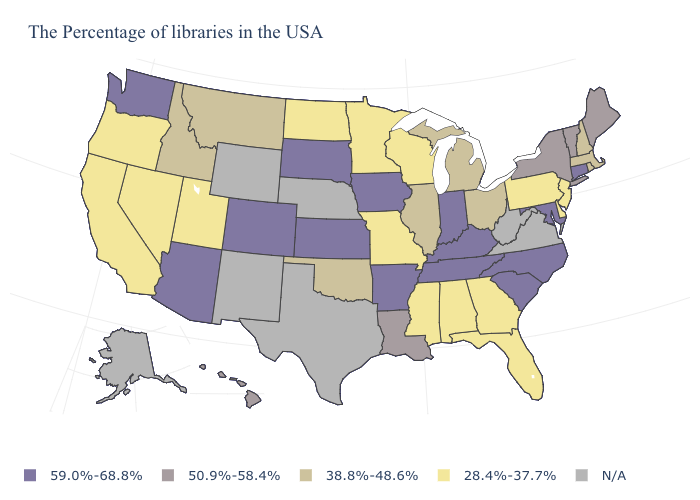Does the first symbol in the legend represent the smallest category?
Short answer required. No. What is the value of Vermont?
Concise answer only. 50.9%-58.4%. Name the states that have a value in the range 38.8%-48.6%?
Be succinct. Massachusetts, Rhode Island, New Hampshire, Ohio, Michigan, Illinois, Oklahoma, Montana, Idaho. Is the legend a continuous bar?
Quick response, please. No. Does Connecticut have the highest value in the Northeast?
Quick response, please. Yes. Does the first symbol in the legend represent the smallest category?
Keep it brief. No. Name the states that have a value in the range 59.0%-68.8%?
Write a very short answer. Connecticut, Maryland, North Carolina, South Carolina, Kentucky, Indiana, Tennessee, Arkansas, Iowa, Kansas, South Dakota, Colorado, Arizona, Washington. What is the highest value in the West ?
Concise answer only. 59.0%-68.8%. What is the value of Utah?
Concise answer only. 28.4%-37.7%. What is the value of Utah?
Short answer required. 28.4%-37.7%. What is the highest value in the USA?
Quick response, please. 59.0%-68.8%. Does Missouri have the lowest value in the MidWest?
Give a very brief answer. Yes. How many symbols are there in the legend?
Write a very short answer. 5. 